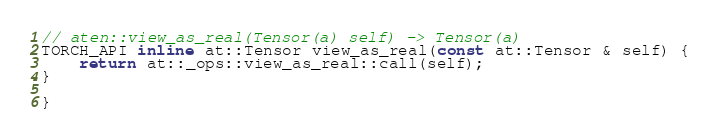Convert code to text. <code><loc_0><loc_0><loc_500><loc_500><_C_>
// aten::view_as_real(Tensor(a) self) -> Tensor(a)
TORCH_API inline at::Tensor view_as_real(const at::Tensor & self) {
    return at::_ops::view_as_real::call(self);
}

}
</code> 